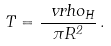<formula> <loc_0><loc_0><loc_500><loc_500>T = \frac { \ v r h o _ { H } } { \pi R ^ { 2 } } \, .</formula> 